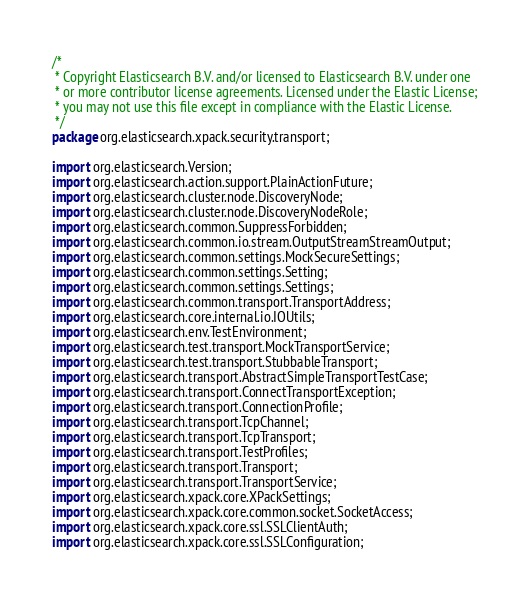Convert code to text. <code><loc_0><loc_0><loc_500><loc_500><_Java_>/*
 * Copyright Elasticsearch B.V. and/or licensed to Elasticsearch B.V. under one
 * or more contributor license agreements. Licensed under the Elastic License;
 * you may not use this file except in compliance with the Elastic License.
 */
package org.elasticsearch.xpack.security.transport;

import org.elasticsearch.Version;
import org.elasticsearch.action.support.PlainActionFuture;
import org.elasticsearch.cluster.node.DiscoveryNode;
import org.elasticsearch.cluster.node.DiscoveryNodeRole;
import org.elasticsearch.common.SuppressForbidden;
import org.elasticsearch.common.io.stream.OutputStreamStreamOutput;
import org.elasticsearch.common.settings.MockSecureSettings;
import org.elasticsearch.common.settings.Setting;
import org.elasticsearch.common.settings.Settings;
import org.elasticsearch.common.transport.TransportAddress;
import org.elasticsearch.core.internal.io.IOUtils;
import org.elasticsearch.env.TestEnvironment;
import org.elasticsearch.test.transport.MockTransportService;
import org.elasticsearch.test.transport.StubbableTransport;
import org.elasticsearch.transport.AbstractSimpleTransportTestCase;
import org.elasticsearch.transport.ConnectTransportException;
import org.elasticsearch.transport.ConnectionProfile;
import org.elasticsearch.transport.TcpChannel;
import org.elasticsearch.transport.TcpTransport;
import org.elasticsearch.transport.TestProfiles;
import org.elasticsearch.transport.Transport;
import org.elasticsearch.transport.TransportService;
import org.elasticsearch.xpack.core.XPackSettings;
import org.elasticsearch.xpack.core.common.socket.SocketAccess;
import org.elasticsearch.xpack.core.ssl.SSLClientAuth;
import org.elasticsearch.xpack.core.ssl.SSLConfiguration;</code> 